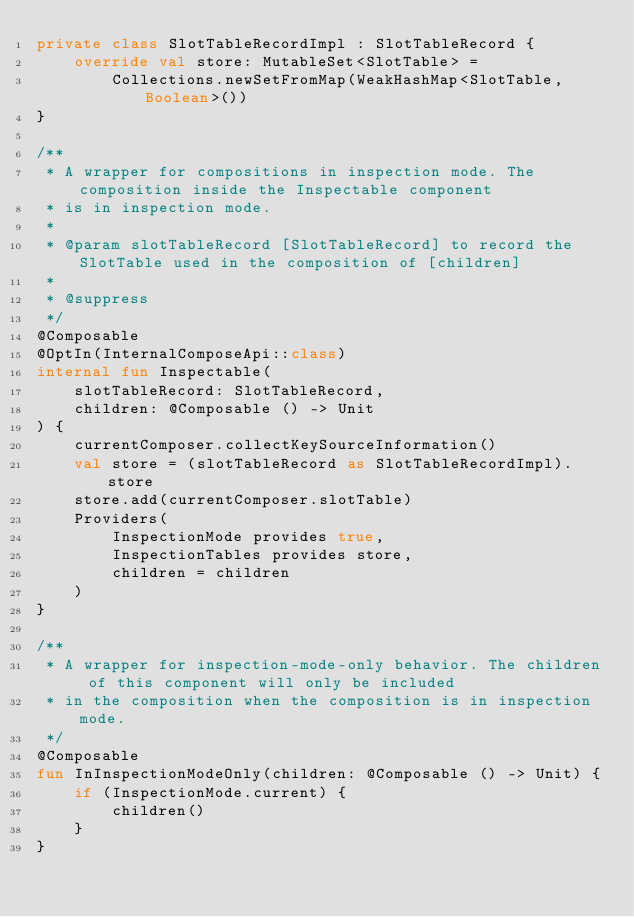<code> <loc_0><loc_0><loc_500><loc_500><_Kotlin_>private class SlotTableRecordImpl : SlotTableRecord {
    override val store: MutableSet<SlotTable> =
        Collections.newSetFromMap(WeakHashMap<SlotTable, Boolean>())
}

/**
 * A wrapper for compositions in inspection mode. The composition inside the Inspectable component
 * is in inspection mode.
 *
 * @param slotTableRecord [SlotTableRecord] to record the SlotTable used in the composition of [children]
 *
 * @suppress
 */
@Composable
@OptIn(InternalComposeApi::class)
internal fun Inspectable(
    slotTableRecord: SlotTableRecord,
    children: @Composable () -> Unit
) {
    currentComposer.collectKeySourceInformation()
    val store = (slotTableRecord as SlotTableRecordImpl).store
    store.add(currentComposer.slotTable)
    Providers(
        InspectionMode provides true,
        InspectionTables provides store,
        children = children
    )
}

/**
 * A wrapper for inspection-mode-only behavior. The children of this component will only be included
 * in the composition when the composition is in inspection mode.
 */
@Composable
fun InInspectionModeOnly(children: @Composable () -> Unit) {
    if (InspectionMode.current) {
        children()
    }
}
</code> 